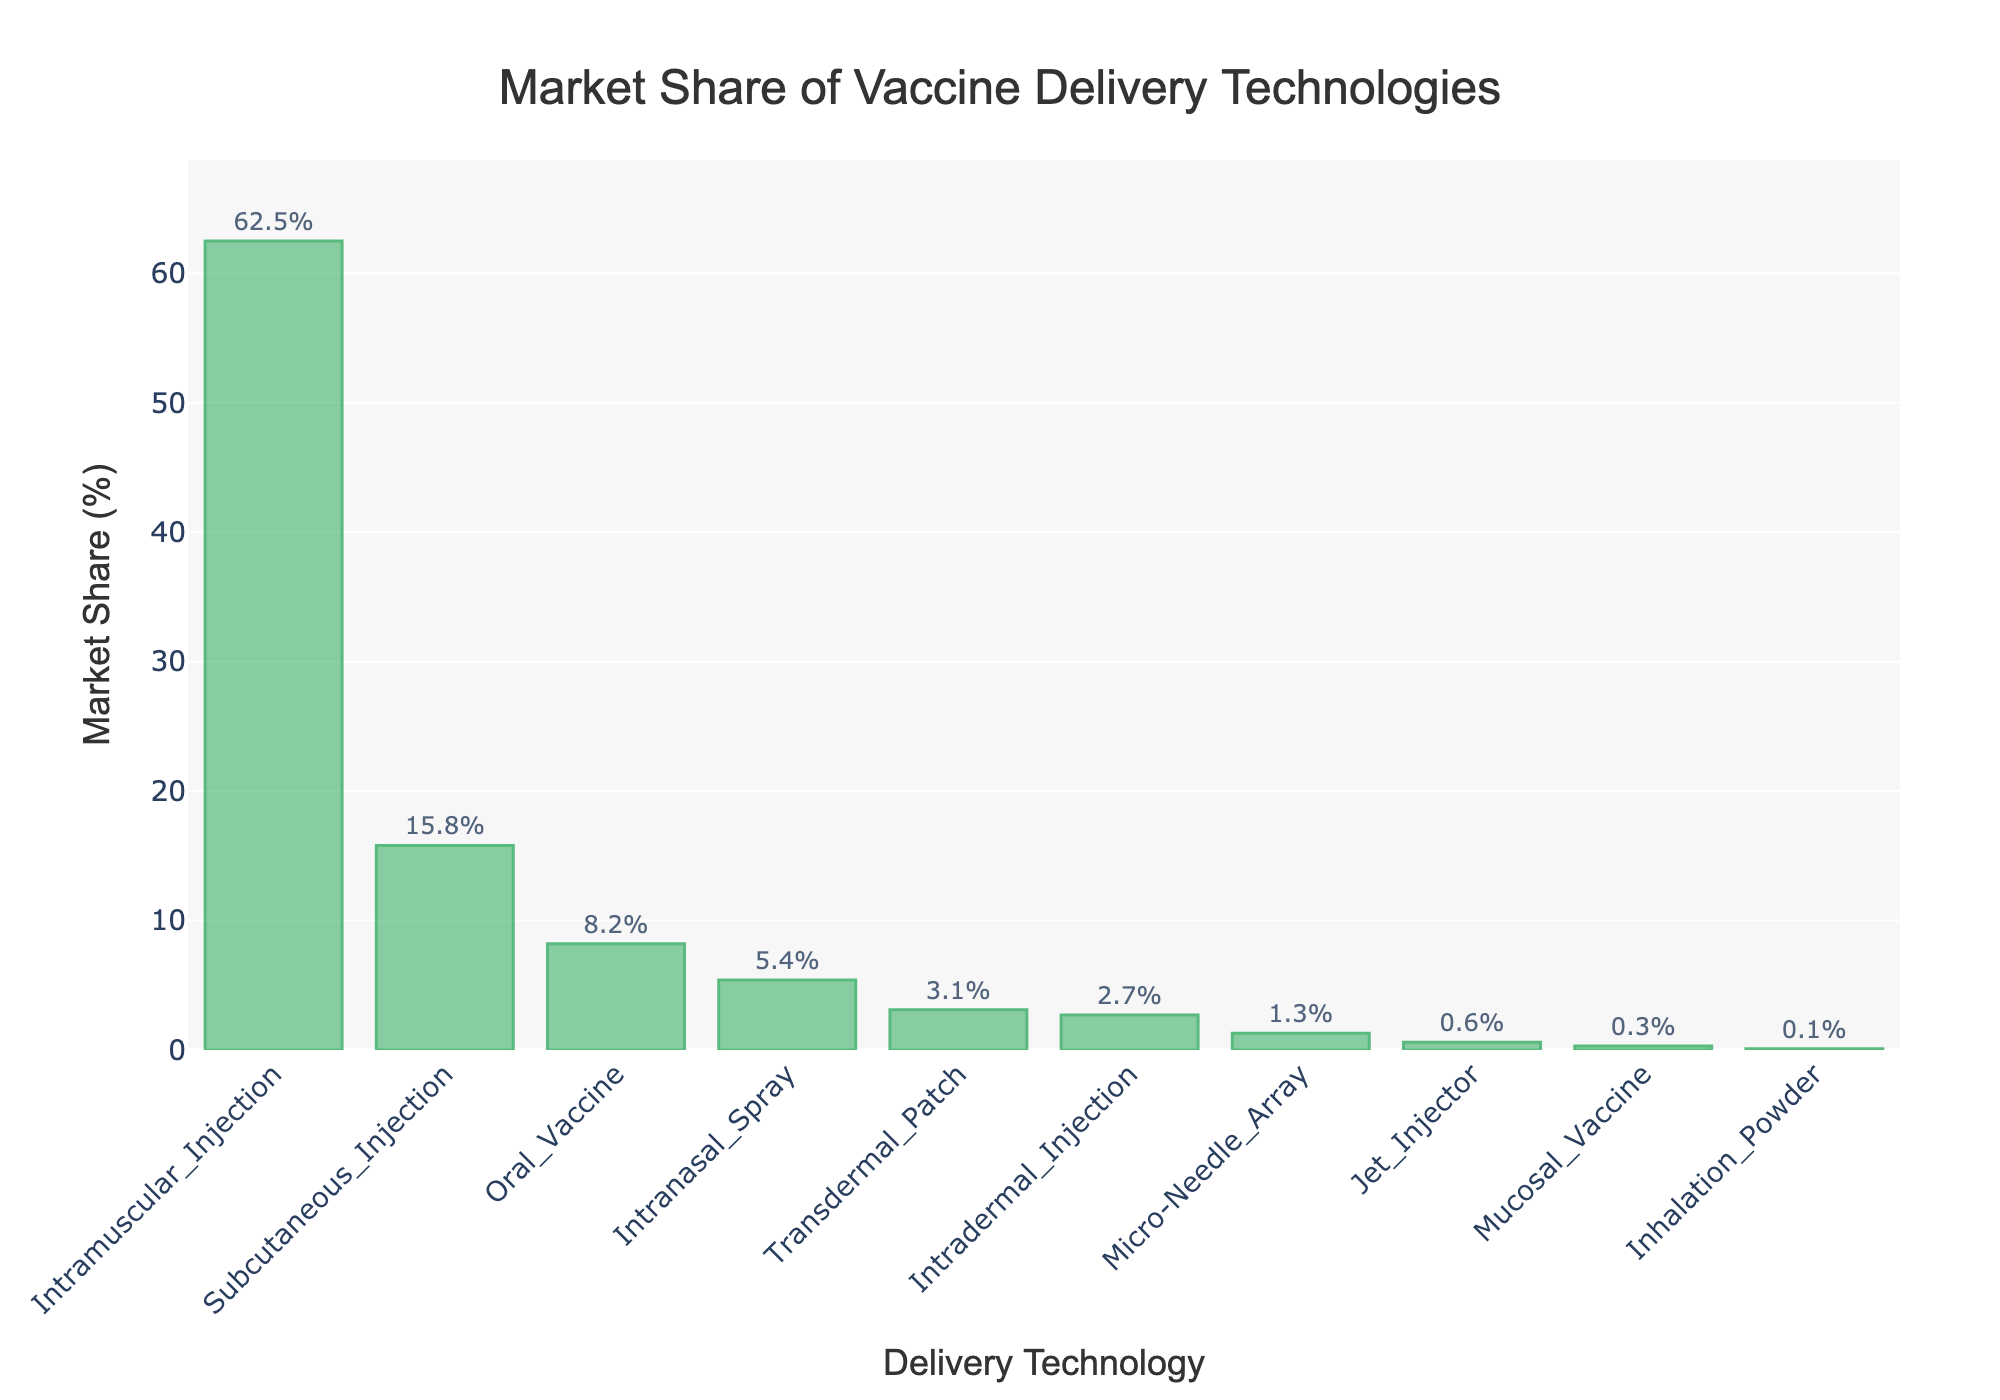What delivery technology holds the largest market share? The bar representing 'Intramuscular Injection' is the tallest, indicating it has the highest percentage.
Answer: Intramuscular Injection What is the total market share of Oral Vaccine, Intranasal Spray, and Transdermal Patch combined? Add the percentages for Oral Vaccine (8.2%), Intranasal Spray (5.4%), and Transdermal Patch (3.1%): 8.2 + 5.4 + 3.1 = 16.7%.
Answer: 16.7% Which has a greater market share: Subcutaneous Injection or Oral Vaccine? Subcutaneous Injection has 15.8%, whereas Oral Vaccine has 8.2%. 15.8% is greater than 8.2%.
Answer: Subcutaneous Injection How does the market share of Jet Injector compare to Mucosal Vaccine? The bar for Jet Injector is slightly taller than that for Mucosal Vaccine. Jet Injector has 0.6%, while Mucosal Vaccine has 0.3%. 0.6% is greater than 0.3%.
Answer: Jet Injector What is the difference in market share percentage between Intramuscular Injection and Micro-Needle Array? Intramuscular Injection has 62.5%, and Micro-Needle Array has 1.3%. The difference is 62.5 - 1.3 = 61.2%.
Answer: 61.2% What is the average market share of the three least popular delivery technologies? The least popular technologies are Inhalation Powder (0.1%), Mucosal Vaccine (0.3%), and Jet Injector (0.6%). Their average is (0.1 + 0.3 + 0.6)/3 = 0.333%.
Answer: 0.333% Which delivery technology has nearly double the market share of Intranasal Spray? The market share of Intranasal Spray is 5.4%. When checking other values around 10.8% (double this value), Subcutaneous Injection at 15.8% is closest but still not exactly double.
Answer: None How many delivery technologies have a market share of less than 5%? Count the bars with market shares below 5%: Oral Vaccine (8.2% is above), Intranasal Spray (5.4% is above), Transdermal Patch (3.1%), Intradermal Injection (2.7%), Micro-Needle Array (1.3%), Jet Injector (0.6%), Mucosal Vaccine (0.3%), Inhalation Powder (0.1%). There are 7 such technologies.
Answer: 7 Which delivery technology comes closest in market share to Intradermal Injection? Intradermal Injection has 2.7%. The closest value is Micro-Needle Array with 1.3%. The difference is 2.7 - 1.3 = 1.4%.
Answer: Micro-Needle Array 